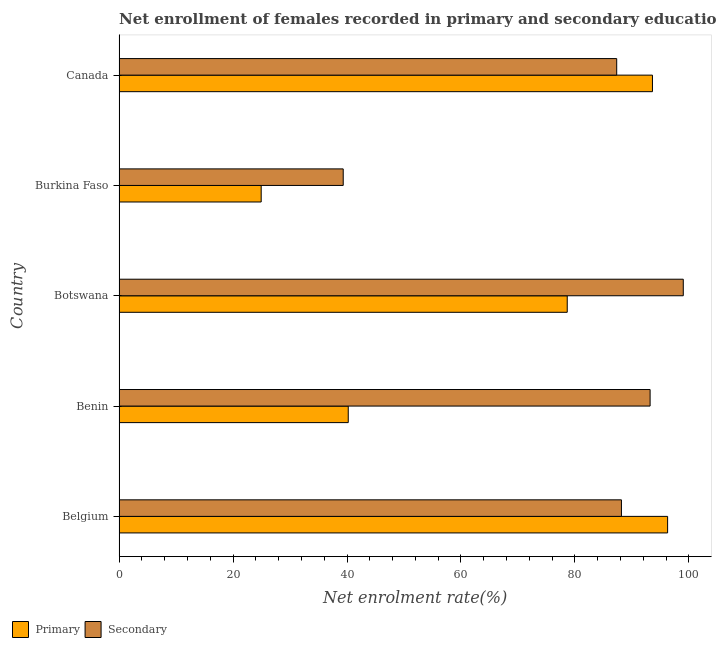How many different coloured bars are there?
Provide a succinct answer. 2. How many groups of bars are there?
Keep it short and to the point. 5. How many bars are there on the 3rd tick from the bottom?
Your answer should be compact. 2. What is the label of the 3rd group of bars from the top?
Provide a short and direct response. Botswana. What is the enrollment rate in primary education in Burkina Faso?
Provide a succinct answer. 24.94. Across all countries, what is the maximum enrollment rate in secondary education?
Offer a terse response. 99.01. Across all countries, what is the minimum enrollment rate in primary education?
Your answer should be very brief. 24.94. In which country was the enrollment rate in primary education minimum?
Your response must be concise. Burkina Faso. What is the total enrollment rate in primary education in the graph?
Offer a terse response. 333.67. What is the difference between the enrollment rate in secondary education in Belgium and that in Botswana?
Provide a short and direct response. -10.85. What is the difference between the enrollment rate in secondary education in Benin and the enrollment rate in primary education in Belgium?
Your response must be concise. -3.07. What is the average enrollment rate in secondary education per country?
Keep it short and to the point. 81.41. What is the difference between the enrollment rate in primary education and enrollment rate in secondary education in Burkina Faso?
Give a very brief answer. -14.39. What is the ratio of the enrollment rate in primary education in Belgium to that in Burkina Faso?
Provide a succinct answer. 3.86. Is the enrollment rate in primary education in Belgium less than that in Benin?
Your answer should be compact. No. What is the difference between the highest and the second highest enrollment rate in primary education?
Your answer should be very brief. 2.66. What is the difference between the highest and the lowest enrollment rate in secondary education?
Ensure brevity in your answer.  59.67. What does the 2nd bar from the top in Burkina Faso represents?
Provide a succinct answer. Primary. What does the 1st bar from the bottom in Canada represents?
Offer a very short reply. Primary. Are all the bars in the graph horizontal?
Your answer should be compact. Yes. How many countries are there in the graph?
Provide a short and direct response. 5. Are the values on the major ticks of X-axis written in scientific E-notation?
Provide a short and direct response. No. Where does the legend appear in the graph?
Ensure brevity in your answer.  Bottom left. How many legend labels are there?
Ensure brevity in your answer.  2. How are the legend labels stacked?
Ensure brevity in your answer.  Horizontal. What is the title of the graph?
Your answer should be very brief. Net enrollment of females recorded in primary and secondary education in year 1995. What is the label or title of the X-axis?
Offer a very short reply. Net enrolment rate(%). What is the Net enrolment rate(%) of Primary in Belgium?
Your response must be concise. 96.26. What is the Net enrolment rate(%) in Secondary in Belgium?
Your answer should be compact. 88.16. What is the Net enrolment rate(%) of Primary in Benin?
Your answer should be compact. 40.22. What is the Net enrolment rate(%) in Secondary in Benin?
Your answer should be very brief. 93.19. What is the Net enrolment rate(%) of Primary in Botswana?
Provide a short and direct response. 78.65. What is the Net enrolment rate(%) in Secondary in Botswana?
Your answer should be very brief. 99.01. What is the Net enrolment rate(%) of Primary in Burkina Faso?
Offer a very short reply. 24.94. What is the Net enrolment rate(%) in Secondary in Burkina Faso?
Your response must be concise. 39.34. What is the Net enrolment rate(%) in Primary in Canada?
Your answer should be compact. 93.6. What is the Net enrolment rate(%) in Secondary in Canada?
Offer a terse response. 87.33. Across all countries, what is the maximum Net enrolment rate(%) in Primary?
Make the answer very short. 96.26. Across all countries, what is the maximum Net enrolment rate(%) in Secondary?
Make the answer very short. 99.01. Across all countries, what is the minimum Net enrolment rate(%) in Primary?
Provide a succinct answer. 24.94. Across all countries, what is the minimum Net enrolment rate(%) of Secondary?
Keep it short and to the point. 39.34. What is the total Net enrolment rate(%) of Primary in the graph?
Your response must be concise. 333.67. What is the total Net enrolment rate(%) in Secondary in the graph?
Give a very brief answer. 407.03. What is the difference between the Net enrolment rate(%) of Primary in Belgium and that in Benin?
Make the answer very short. 56.04. What is the difference between the Net enrolment rate(%) in Secondary in Belgium and that in Benin?
Provide a succinct answer. -5.03. What is the difference between the Net enrolment rate(%) of Primary in Belgium and that in Botswana?
Provide a short and direct response. 17.61. What is the difference between the Net enrolment rate(%) in Secondary in Belgium and that in Botswana?
Your answer should be compact. -10.85. What is the difference between the Net enrolment rate(%) of Primary in Belgium and that in Burkina Faso?
Your answer should be compact. 71.32. What is the difference between the Net enrolment rate(%) of Secondary in Belgium and that in Burkina Faso?
Provide a succinct answer. 48.82. What is the difference between the Net enrolment rate(%) of Primary in Belgium and that in Canada?
Provide a short and direct response. 2.66. What is the difference between the Net enrolment rate(%) of Secondary in Belgium and that in Canada?
Provide a short and direct response. 0.83. What is the difference between the Net enrolment rate(%) of Primary in Benin and that in Botswana?
Offer a very short reply. -38.43. What is the difference between the Net enrolment rate(%) in Secondary in Benin and that in Botswana?
Make the answer very short. -5.82. What is the difference between the Net enrolment rate(%) of Primary in Benin and that in Burkina Faso?
Offer a very short reply. 15.28. What is the difference between the Net enrolment rate(%) of Secondary in Benin and that in Burkina Faso?
Provide a succinct answer. 53.85. What is the difference between the Net enrolment rate(%) of Primary in Benin and that in Canada?
Your response must be concise. -53.38. What is the difference between the Net enrolment rate(%) in Secondary in Benin and that in Canada?
Keep it short and to the point. 5.86. What is the difference between the Net enrolment rate(%) of Primary in Botswana and that in Burkina Faso?
Provide a succinct answer. 53.71. What is the difference between the Net enrolment rate(%) of Secondary in Botswana and that in Burkina Faso?
Give a very brief answer. 59.67. What is the difference between the Net enrolment rate(%) of Primary in Botswana and that in Canada?
Make the answer very short. -14.95. What is the difference between the Net enrolment rate(%) in Secondary in Botswana and that in Canada?
Offer a terse response. 11.68. What is the difference between the Net enrolment rate(%) in Primary in Burkina Faso and that in Canada?
Your answer should be compact. -68.66. What is the difference between the Net enrolment rate(%) in Secondary in Burkina Faso and that in Canada?
Make the answer very short. -47.99. What is the difference between the Net enrolment rate(%) in Primary in Belgium and the Net enrolment rate(%) in Secondary in Benin?
Provide a succinct answer. 3.07. What is the difference between the Net enrolment rate(%) in Primary in Belgium and the Net enrolment rate(%) in Secondary in Botswana?
Your answer should be very brief. -2.75. What is the difference between the Net enrolment rate(%) in Primary in Belgium and the Net enrolment rate(%) in Secondary in Burkina Faso?
Keep it short and to the point. 56.92. What is the difference between the Net enrolment rate(%) in Primary in Belgium and the Net enrolment rate(%) in Secondary in Canada?
Make the answer very short. 8.93. What is the difference between the Net enrolment rate(%) of Primary in Benin and the Net enrolment rate(%) of Secondary in Botswana?
Provide a succinct answer. -58.79. What is the difference between the Net enrolment rate(%) in Primary in Benin and the Net enrolment rate(%) in Secondary in Burkina Faso?
Offer a very short reply. 0.88. What is the difference between the Net enrolment rate(%) in Primary in Benin and the Net enrolment rate(%) in Secondary in Canada?
Keep it short and to the point. -47.11. What is the difference between the Net enrolment rate(%) of Primary in Botswana and the Net enrolment rate(%) of Secondary in Burkina Faso?
Your answer should be very brief. 39.31. What is the difference between the Net enrolment rate(%) of Primary in Botswana and the Net enrolment rate(%) of Secondary in Canada?
Keep it short and to the point. -8.68. What is the difference between the Net enrolment rate(%) in Primary in Burkina Faso and the Net enrolment rate(%) in Secondary in Canada?
Provide a short and direct response. -62.39. What is the average Net enrolment rate(%) of Primary per country?
Provide a short and direct response. 66.73. What is the average Net enrolment rate(%) in Secondary per country?
Keep it short and to the point. 81.41. What is the difference between the Net enrolment rate(%) in Primary and Net enrolment rate(%) in Secondary in Belgium?
Provide a short and direct response. 8.1. What is the difference between the Net enrolment rate(%) of Primary and Net enrolment rate(%) of Secondary in Benin?
Ensure brevity in your answer.  -52.97. What is the difference between the Net enrolment rate(%) in Primary and Net enrolment rate(%) in Secondary in Botswana?
Your response must be concise. -20.36. What is the difference between the Net enrolment rate(%) of Primary and Net enrolment rate(%) of Secondary in Burkina Faso?
Give a very brief answer. -14.4. What is the difference between the Net enrolment rate(%) of Primary and Net enrolment rate(%) of Secondary in Canada?
Make the answer very short. 6.27. What is the ratio of the Net enrolment rate(%) in Primary in Belgium to that in Benin?
Your answer should be compact. 2.39. What is the ratio of the Net enrolment rate(%) of Secondary in Belgium to that in Benin?
Offer a very short reply. 0.95. What is the ratio of the Net enrolment rate(%) of Primary in Belgium to that in Botswana?
Keep it short and to the point. 1.22. What is the ratio of the Net enrolment rate(%) in Secondary in Belgium to that in Botswana?
Give a very brief answer. 0.89. What is the ratio of the Net enrolment rate(%) in Primary in Belgium to that in Burkina Faso?
Offer a very short reply. 3.86. What is the ratio of the Net enrolment rate(%) of Secondary in Belgium to that in Burkina Faso?
Your answer should be very brief. 2.24. What is the ratio of the Net enrolment rate(%) in Primary in Belgium to that in Canada?
Ensure brevity in your answer.  1.03. What is the ratio of the Net enrolment rate(%) of Secondary in Belgium to that in Canada?
Provide a short and direct response. 1.01. What is the ratio of the Net enrolment rate(%) of Primary in Benin to that in Botswana?
Your answer should be very brief. 0.51. What is the ratio of the Net enrolment rate(%) in Secondary in Benin to that in Botswana?
Your answer should be very brief. 0.94. What is the ratio of the Net enrolment rate(%) in Primary in Benin to that in Burkina Faso?
Your answer should be very brief. 1.61. What is the ratio of the Net enrolment rate(%) in Secondary in Benin to that in Burkina Faso?
Ensure brevity in your answer.  2.37. What is the ratio of the Net enrolment rate(%) of Primary in Benin to that in Canada?
Provide a succinct answer. 0.43. What is the ratio of the Net enrolment rate(%) in Secondary in Benin to that in Canada?
Offer a very short reply. 1.07. What is the ratio of the Net enrolment rate(%) in Primary in Botswana to that in Burkina Faso?
Provide a succinct answer. 3.15. What is the ratio of the Net enrolment rate(%) of Secondary in Botswana to that in Burkina Faso?
Offer a terse response. 2.52. What is the ratio of the Net enrolment rate(%) in Primary in Botswana to that in Canada?
Offer a very short reply. 0.84. What is the ratio of the Net enrolment rate(%) of Secondary in Botswana to that in Canada?
Your answer should be very brief. 1.13. What is the ratio of the Net enrolment rate(%) in Primary in Burkina Faso to that in Canada?
Your response must be concise. 0.27. What is the ratio of the Net enrolment rate(%) of Secondary in Burkina Faso to that in Canada?
Your response must be concise. 0.45. What is the difference between the highest and the second highest Net enrolment rate(%) of Primary?
Offer a very short reply. 2.66. What is the difference between the highest and the second highest Net enrolment rate(%) in Secondary?
Give a very brief answer. 5.82. What is the difference between the highest and the lowest Net enrolment rate(%) of Primary?
Provide a succinct answer. 71.32. What is the difference between the highest and the lowest Net enrolment rate(%) in Secondary?
Your response must be concise. 59.67. 